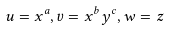<formula> <loc_0><loc_0><loc_500><loc_500>u = x ^ { a } , v = x ^ { b } y ^ { c } , w = z</formula> 